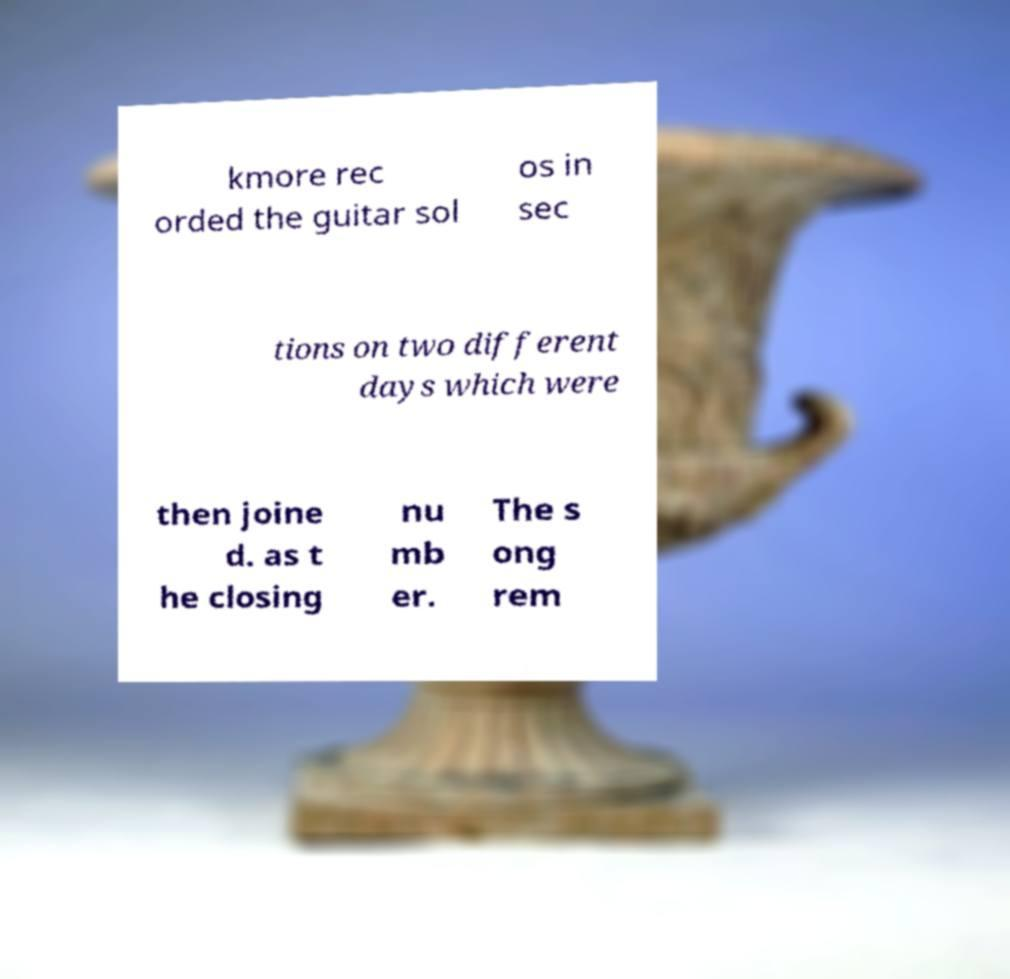Please read and relay the text visible in this image. What does it say? kmore rec orded the guitar sol os in sec tions on two different days which were then joine d. as t he closing nu mb er. The s ong rem 